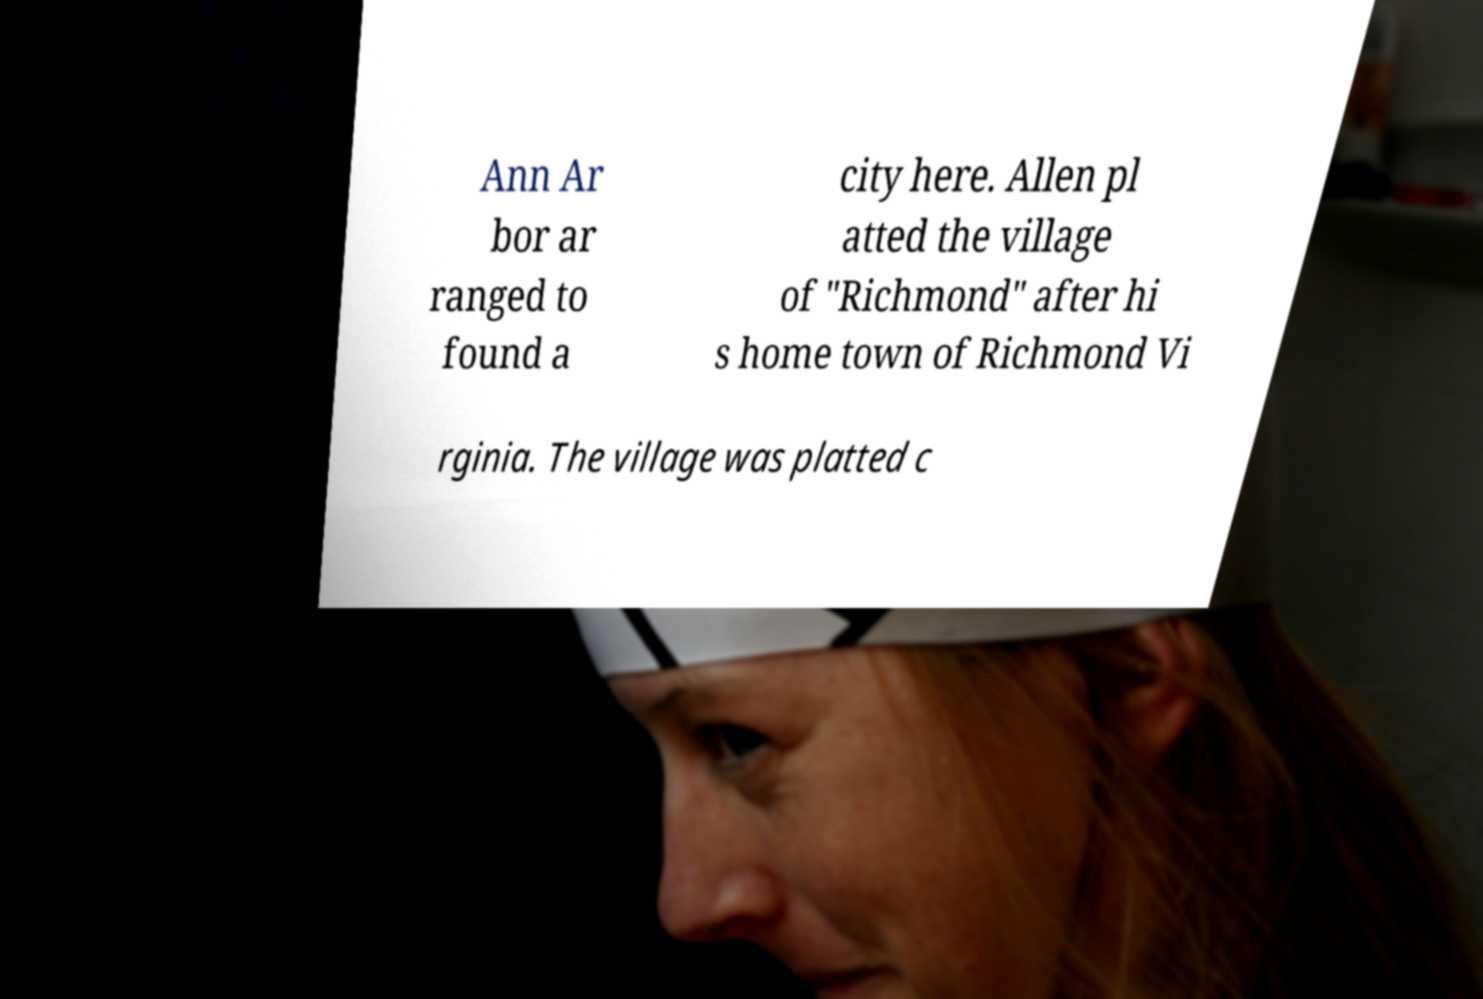Please read and relay the text visible in this image. What does it say? Ann Ar bor ar ranged to found a city here. Allen pl atted the village of "Richmond" after hi s home town of Richmond Vi rginia. The village was platted c 